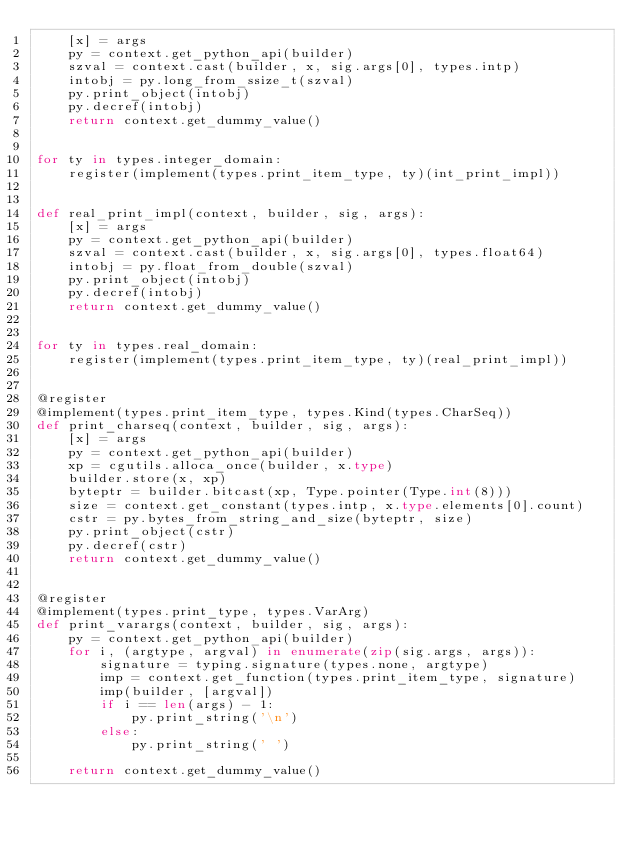Convert code to text. <code><loc_0><loc_0><loc_500><loc_500><_Python_>    [x] = args
    py = context.get_python_api(builder)
    szval = context.cast(builder, x, sig.args[0], types.intp)
    intobj = py.long_from_ssize_t(szval)
    py.print_object(intobj)
    py.decref(intobj)
    return context.get_dummy_value()


for ty in types.integer_domain:
    register(implement(types.print_item_type, ty)(int_print_impl))


def real_print_impl(context, builder, sig, args):
    [x] = args
    py = context.get_python_api(builder)
    szval = context.cast(builder, x, sig.args[0], types.float64)
    intobj = py.float_from_double(szval)
    py.print_object(intobj)
    py.decref(intobj)
    return context.get_dummy_value()


for ty in types.real_domain:
    register(implement(types.print_item_type, ty)(real_print_impl))


@register
@implement(types.print_item_type, types.Kind(types.CharSeq))
def print_charseq(context, builder, sig, args):
    [x] = args
    py = context.get_python_api(builder)
    xp = cgutils.alloca_once(builder, x.type)
    builder.store(x, xp)
    byteptr = builder.bitcast(xp, Type.pointer(Type.int(8)))
    size = context.get_constant(types.intp, x.type.elements[0].count)
    cstr = py.bytes_from_string_and_size(byteptr, size)
    py.print_object(cstr)
    py.decref(cstr)
    return context.get_dummy_value()


@register
@implement(types.print_type, types.VarArg)
def print_varargs(context, builder, sig, args):
    py = context.get_python_api(builder)
    for i, (argtype, argval) in enumerate(zip(sig.args, args)):
        signature = typing.signature(types.none, argtype)
        imp = context.get_function(types.print_item_type, signature)
        imp(builder, [argval])
        if i == len(args) - 1:
            py.print_string('\n')
        else:
            py.print_string(' ')

    return context.get_dummy_value()
</code> 